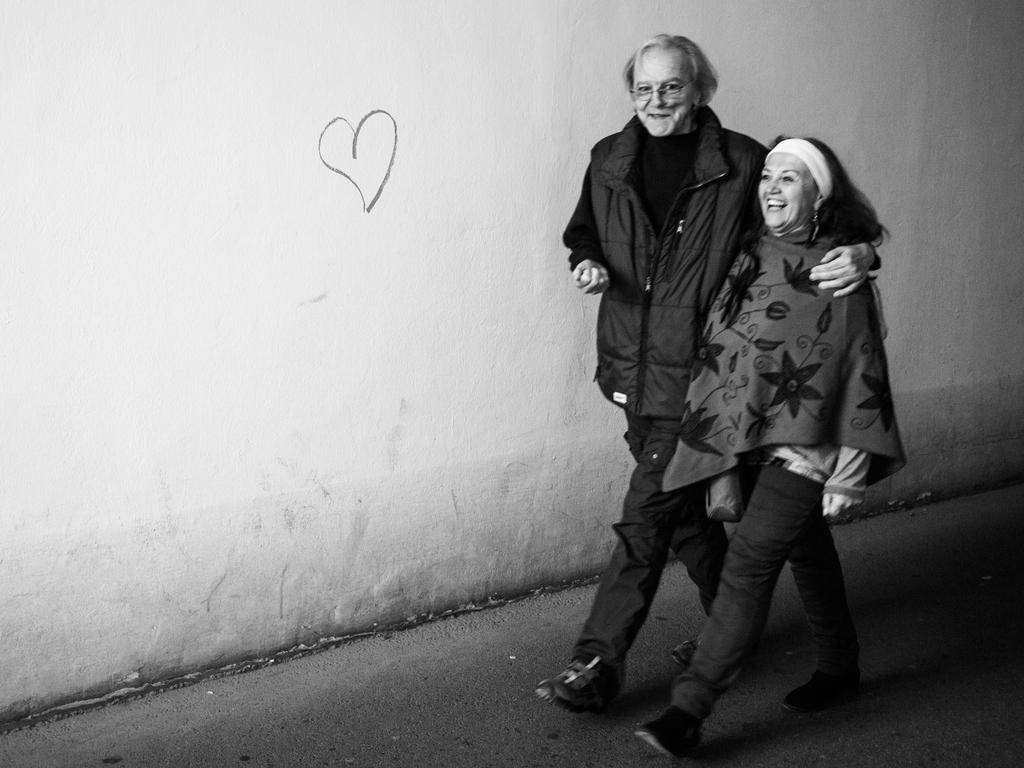Who is present in the image? There is a man and a woman in the image. What are the man and woman doing in the image? The man and woman are walking in the image. What is the emotional state of the man and woman? The man and woman are smiling in the image. What can be seen in the background of the image? There is a wall in the background of the image. What type of feast is being prepared in the background of the image? There is no feast or any indication of food preparation in the image; it only shows a man and a woman walking and smiling, with a wall in the background. 